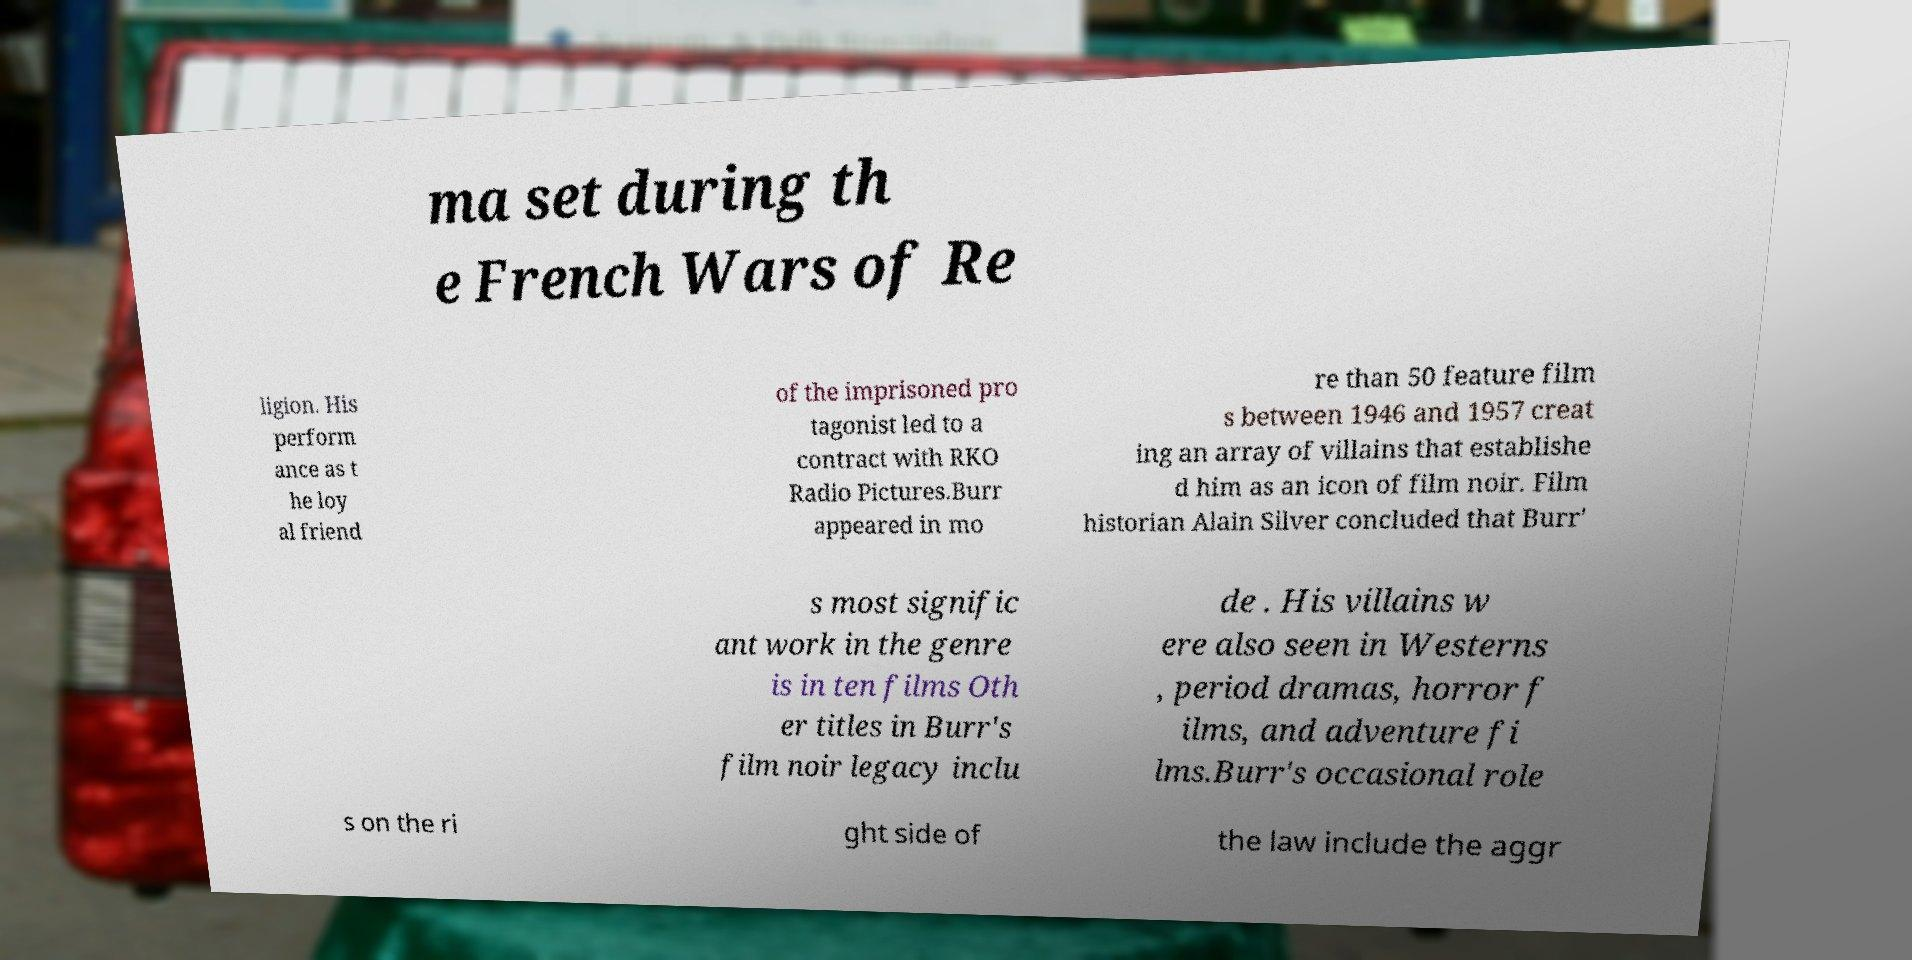Could you extract and type out the text from this image? ma set during th e French Wars of Re ligion. His perform ance as t he loy al friend of the imprisoned pro tagonist led to a contract with RKO Radio Pictures.Burr appeared in mo re than 50 feature film s between 1946 and 1957 creat ing an array of villains that establishe d him as an icon of film noir. Film historian Alain Silver concluded that Burr' s most signific ant work in the genre is in ten films Oth er titles in Burr's film noir legacy inclu de . His villains w ere also seen in Westerns , period dramas, horror f ilms, and adventure fi lms.Burr's occasional role s on the ri ght side of the law include the aggr 